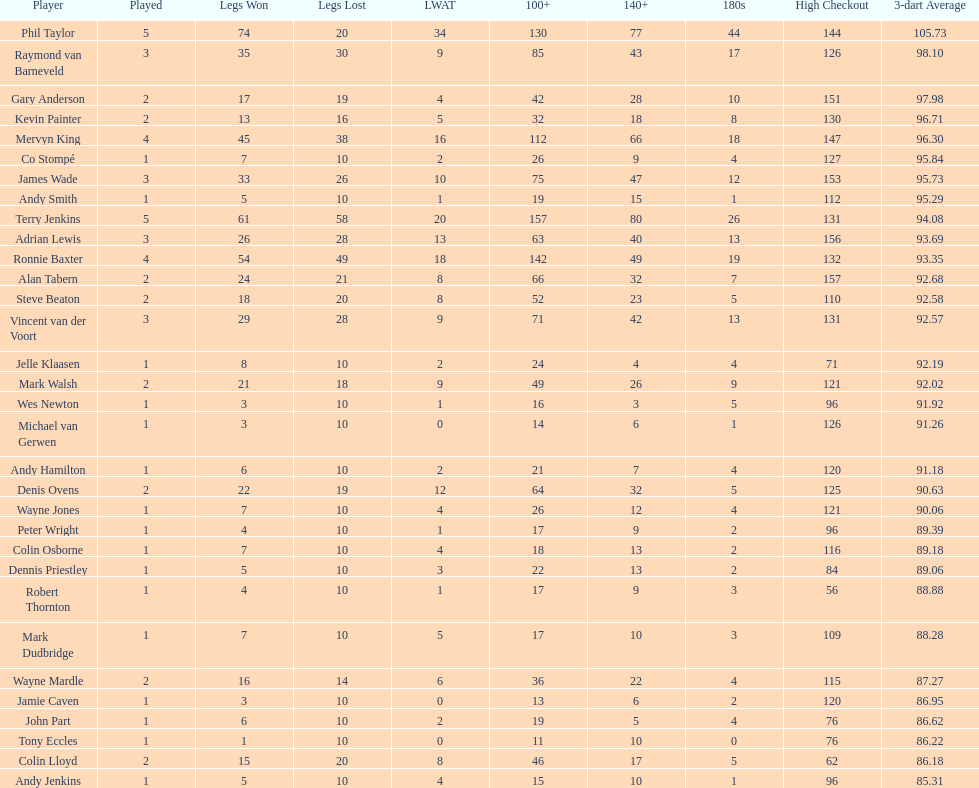Is mark walsh's average higher or lower than 93? Below. 